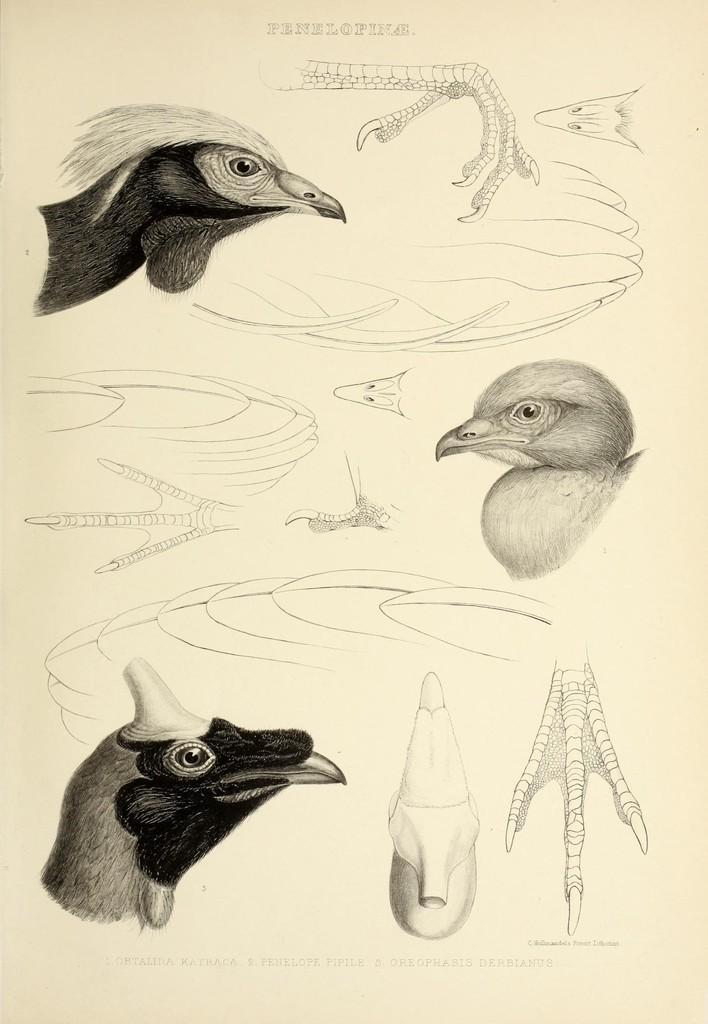Please provide a concise description of this image. In this picture I can see a paper with some drawings and words on it. 